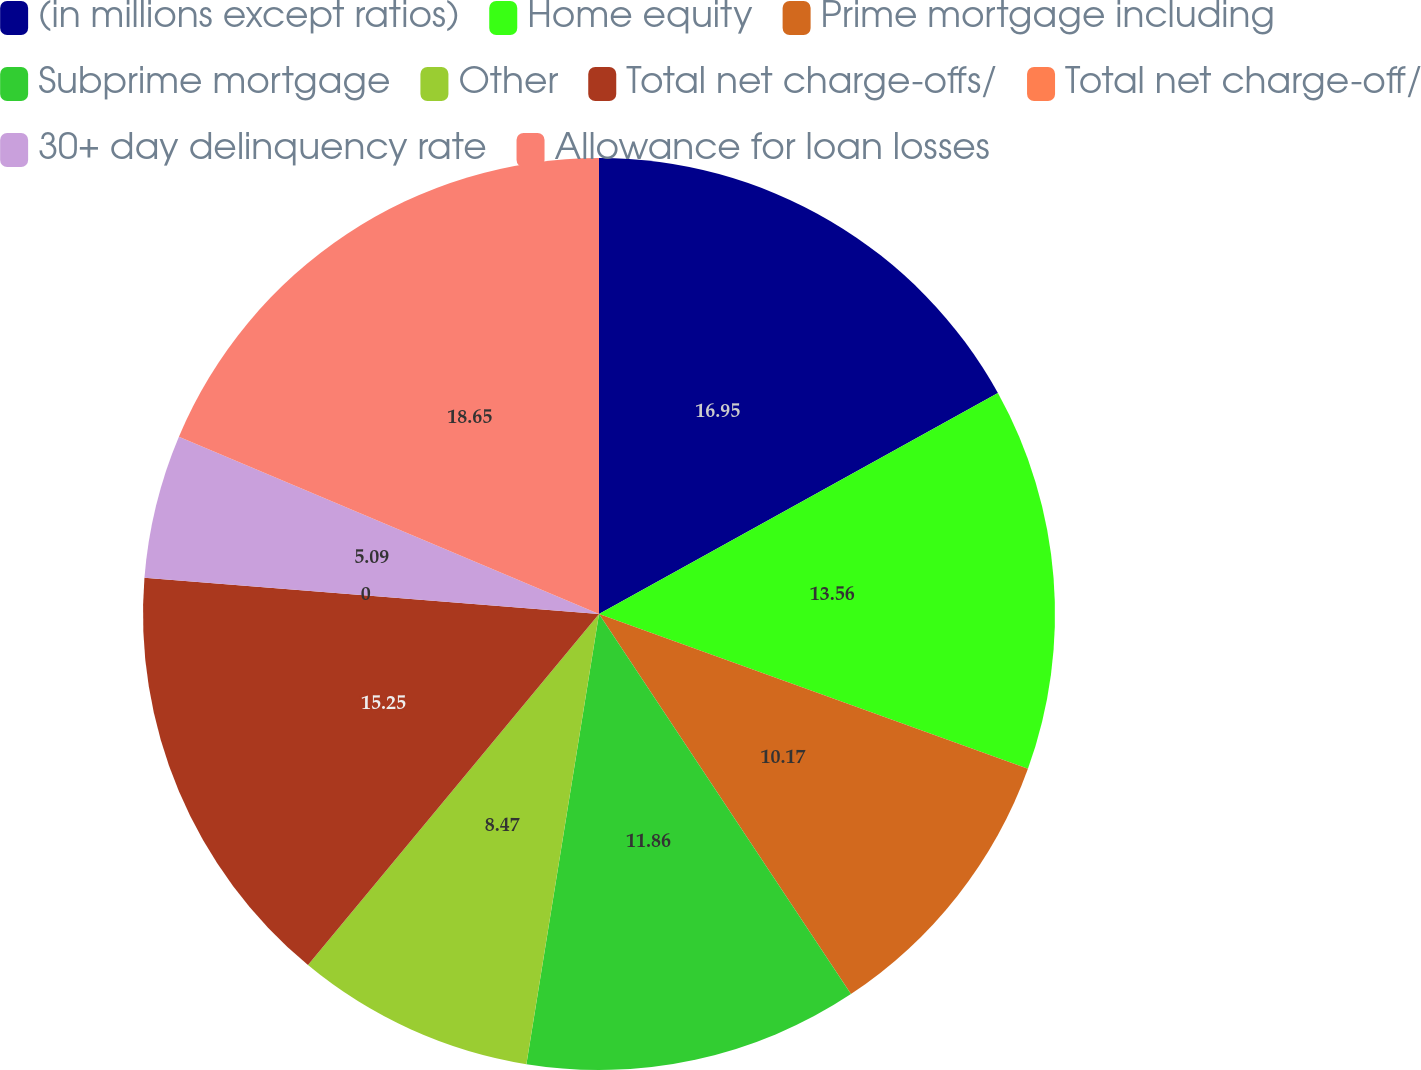<chart> <loc_0><loc_0><loc_500><loc_500><pie_chart><fcel>(in millions except ratios)<fcel>Home equity<fcel>Prime mortgage including<fcel>Subprime mortgage<fcel>Other<fcel>Total net charge-offs/<fcel>Total net charge-off/<fcel>30+ day delinquency rate<fcel>Allowance for loan losses<nl><fcel>16.95%<fcel>13.56%<fcel>10.17%<fcel>11.86%<fcel>8.47%<fcel>15.25%<fcel>0.0%<fcel>5.09%<fcel>18.64%<nl></chart> 